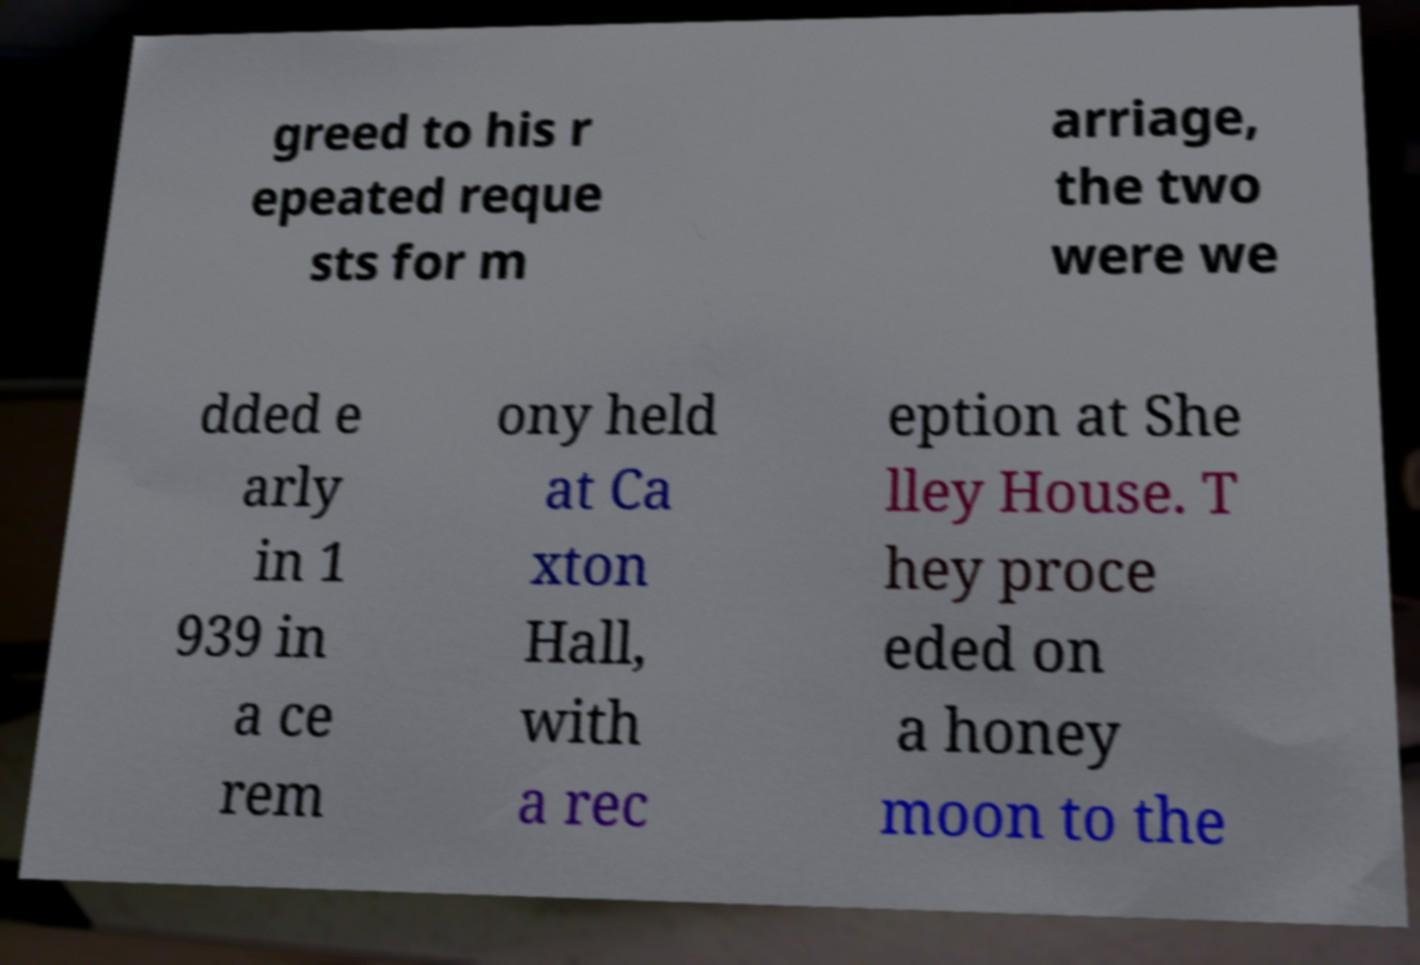Can you accurately transcribe the text from the provided image for me? greed to his r epeated reque sts for m arriage, the two were we dded e arly in 1 939 in a ce rem ony held at Ca xton Hall, with a rec eption at She lley House. T hey proce eded on a honey moon to the 